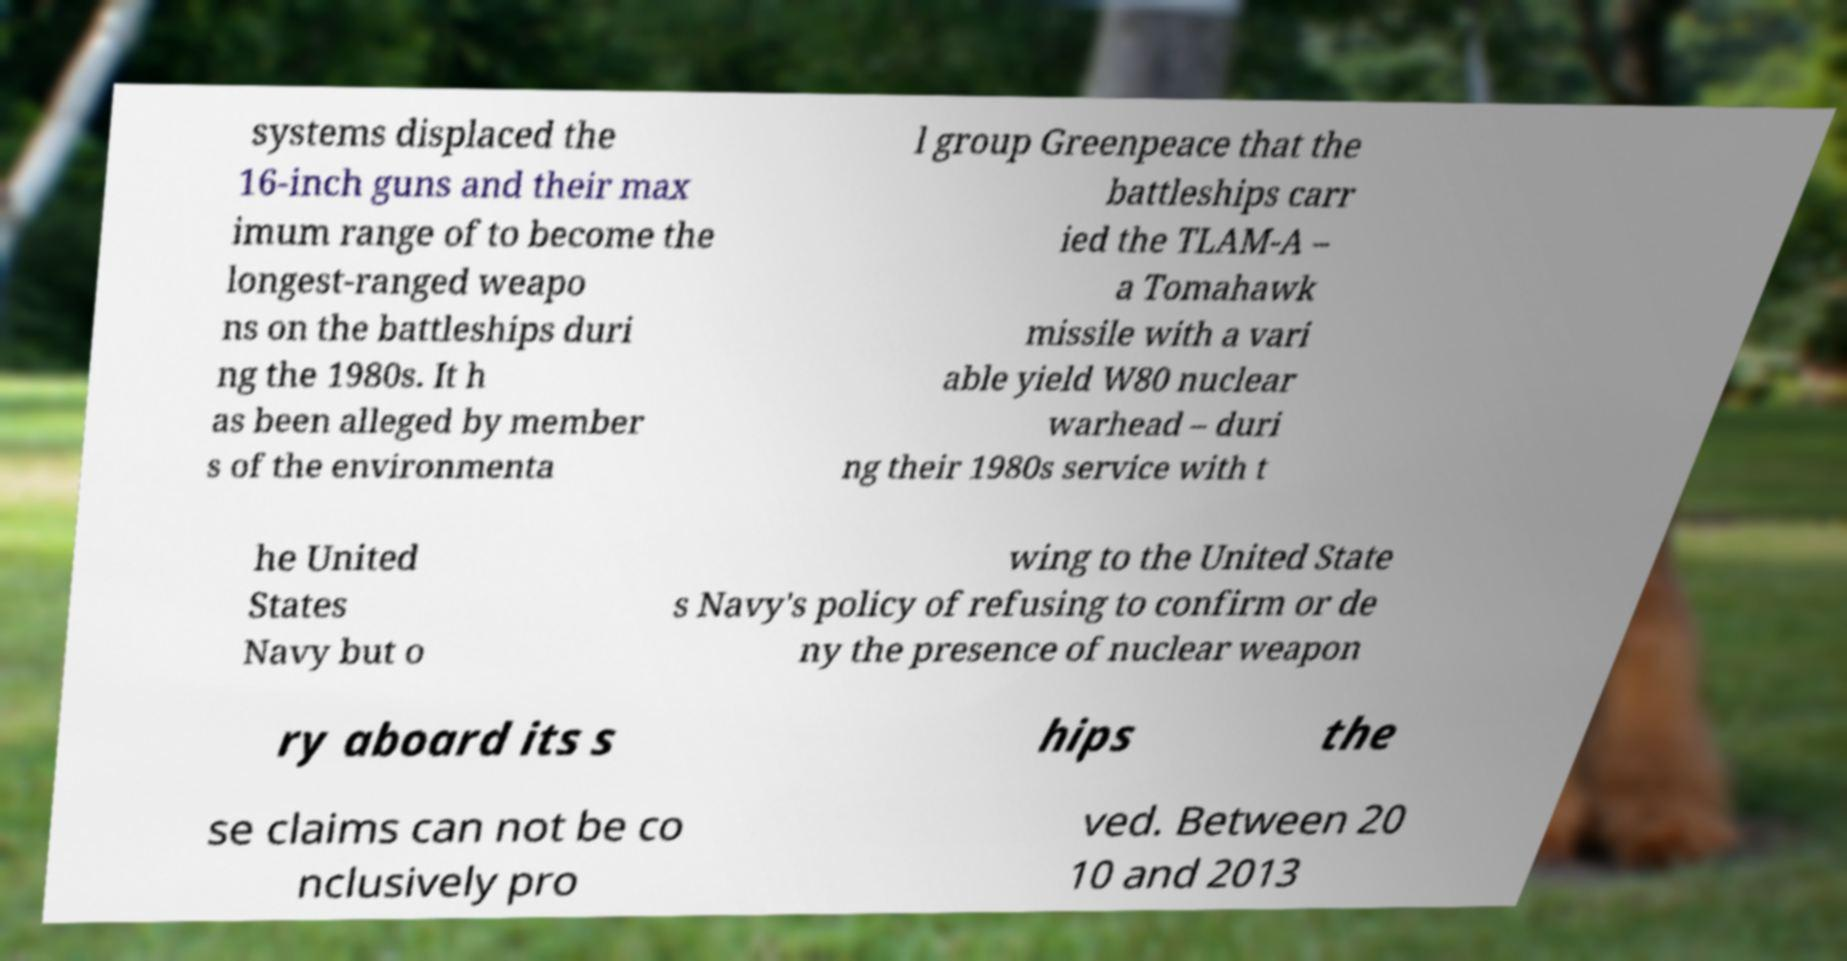Please identify and transcribe the text found in this image. systems displaced the 16-inch guns and their max imum range of to become the longest-ranged weapo ns on the battleships duri ng the 1980s. It h as been alleged by member s of the environmenta l group Greenpeace that the battleships carr ied the TLAM-A – a Tomahawk missile with a vari able yield W80 nuclear warhead – duri ng their 1980s service with t he United States Navy but o wing to the United State s Navy's policy of refusing to confirm or de ny the presence of nuclear weapon ry aboard its s hips the se claims can not be co nclusively pro ved. Between 20 10 and 2013 